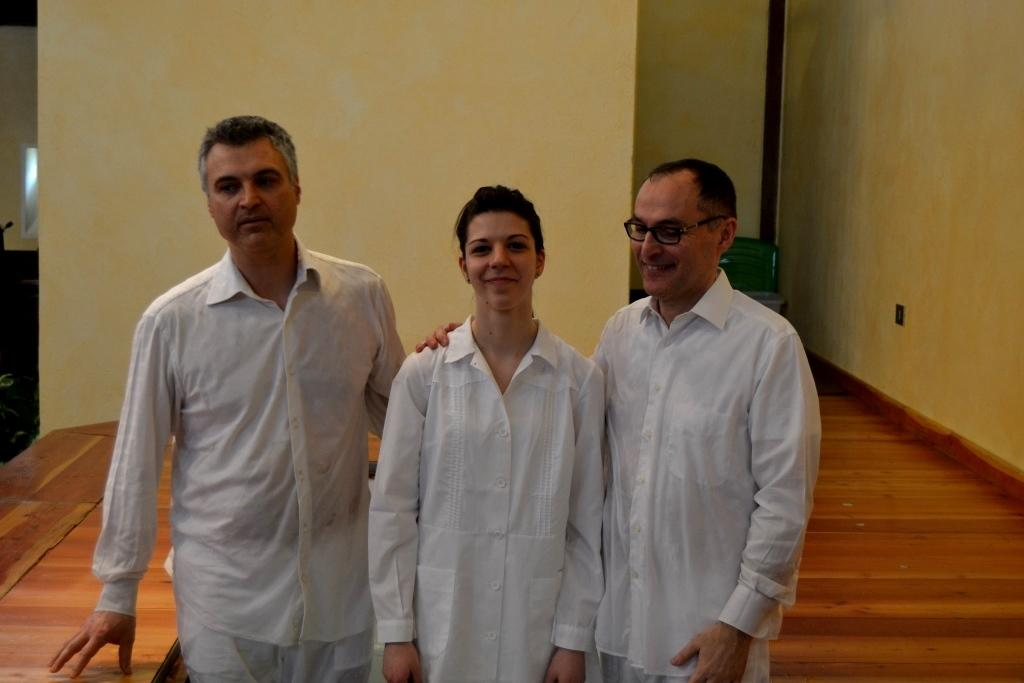How many people are in the image? There are three people in the image: two men and one woman. What are the people wearing in the image? The men and woman are wearing white shirts. What type of flooring is visible in the image? There is a wooden floor in the image. How many gold clocks can be seen hanging on the wall in the image? There are no gold clocks visible in the image. What type of home is shown in the image? The provided facts do not give any information about the type of home or building in the image. 